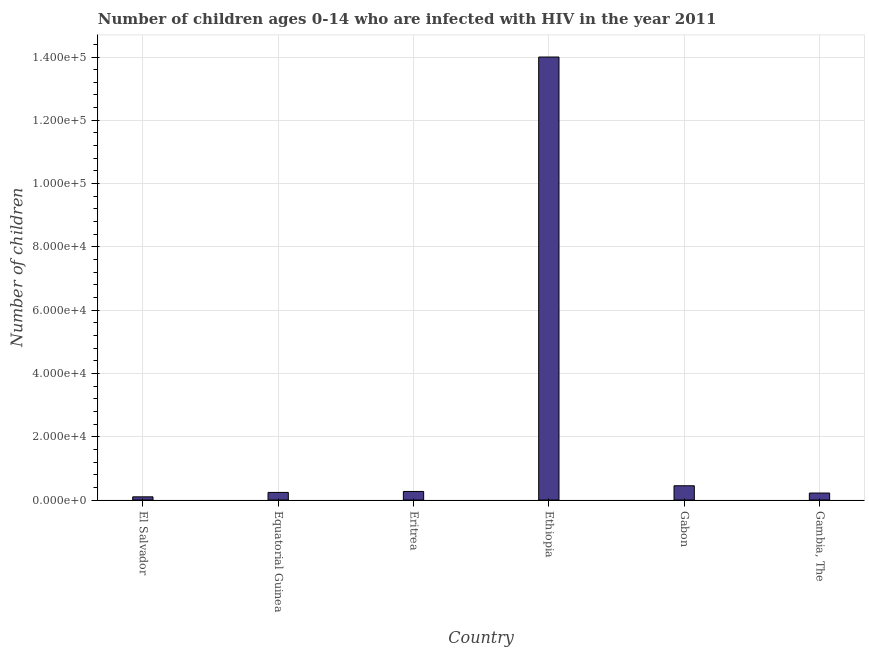Does the graph contain any zero values?
Your answer should be very brief. No. What is the title of the graph?
Provide a short and direct response. Number of children ages 0-14 who are infected with HIV in the year 2011. What is the label or title of the Y-axis?
Make the answer very short. Number of children. What is the number of children living with hiv in Gambia, The?
Your response must be concise. 2200. Across all countries, what is the maximum number of children living with hiv?
Your answer should be very brief. 1.40e+05. In which country was the number of children living with hiv maximum?
Provide a short and direct response. Ethiopia. In which country was the number of children living with hiv minimum?
Your answer should be compact. El Salvador. What is the sum of the number of children living with hiv?
Provide a succinct answer. 1.53e+05. What is the difference between the number of children living with hiv in El Salvador and Eritrea?
Your response must be concise. -1700. What is the average number of children living with hiv per country?
Provide a succinct answer. 2.55e+04. What is the median number of children living with hiv?
Make the answer very short. 2550. In how many countries, is the number of children living with hiv greater than 16000 ?
Offer a very short reply. 1. What is the ratio of the number of children living with hiv in Ethiopia to that in Gabon?
Provide a succinct answer. 31.11. Is the difference between the number of children living with hiv in Equatorial Guinea and Gambia, The greater than the difference between any two countries?
Make the answer very short. No. What is the difference between the highest and the second highest number of children living with hiv?
Make the answer very short. 1.36e+05. What is the difference between the highest and the lowest number of children living with hiv?
Your answer should be very brief. 1.39e+05. How many bars are there?
Ensure brevity in your answer.  6. How many countries are there in the graph?
Your response must be concise. 6. What is the difference between two consecutive major ticks on the Y-axis?
Your answer should be very brief. 2.00e+04. What is the Number of children in Equatorial Guinea?
Your response must be concise. 2400. What is the Number of children in Eritrea?
Your answer should be very brief. 2700. What is the Number of children of Ethiopia?
Your response must be concise. 1.40e+05. What is the Number of children in Gabon?
Keep it short and to the point. 4500. What is the Number of children of Gambia, The?
Offer a terse response. 2200. What is the difference between the Number of children in El Salvador and Equatorial Guinea?
Your answer should be compact. -1400. What is the difference between the Number of children in El Salvador and Eritrea?
Ensure brevity in your answer.  -1700. What is the difference between the Number of children in El Salvador and Ethiopia?
Ensure brevity in your answer.  -1.39e+05. What is the difference between the Number of children in El Salvador and Gabon?
Your answer should be compact. -3500. What is the difference between the Number of children in El Salvador and Gambia, The?
Your response must be concise. -1200. What is the difference between the Number of children in Equatorial Guinea and Eritrea?
Keep it short and to the point. -300. What is the difference between the Number of children in Equatorial Guinea and Ethiopia?
Your answer should be compact. -1.38e+05. What is the difference between the Number of children in Equatorial Guinea and Gabon?
Provide a succinct answer. -2100. What is the difference between the Number of children in Eritrea and Ethiopia?
Provide a succinct answer. -1.37e+05. What is the difference between the Number of children in Eritrea and Gabon?
Provide a short and direct response. -1800. What is the difference between the Number of children in Ethiopia and Gabon?
Keep it short and to the point. 1.36e+05. What is the difference between the Number of children in Ethiopia and Gambia, The?
Give a very brief answer. 1.38e+05. What is the difference between the Number of children in Gabon and Gambia, The?
Provide a short and direct response. 2300. What is the ratio of the Number of children in El Salvador to that in Equatorial Guinea?
Make the answer very short. 0.42. What is the ratio of the Number of children in El Salvador to that in Eritrea?
Offer a terse response. 0.37. What is the ratio of the Number of children in El Salvador to that in Ethiopia?
Offer a terse response. 0.01. What is the ratio of the Number of children in El Salvador to that in Gabon?
Offer a terse response. 0.22. What is the ratio of the Number of children in El Salvador to that in Gambia, The?
Your response must be concise. 0.46. What is the ratio of the Number of children in Equatorial Guinea to that in Eritrea?
Give a very brief answer. 0.89. What is the ratio of the Number of children in Equatorial Guinea to that in Ethiopia?
Provide a short and direct response. 0.02. What is the ratio of the Number of children in Equatorial Guinea to that in Gabon?
Make the answer very short. 0.53. What is the ratio of the Number of children in Equatorial Guinea to that in Gambia, The?
Ensure brevity in your answer.  1.09. What is the ratio of the Number of children in Eritrea to that in Ethiopia?
Give a very brief answer. 0.02. What is the ratio of the Number of children in Eritrea to that in Gabon?
Your answer should be very brief. 0.6. What is the ratio of the Number of children in Eritrea to that in Gambia, The?
Your response must be concise. 1.23. What is the ratio of the Number of children in Ethiopia to that in Gabon?
Keep it short and to the point. 31.11. What is the ratio of the Number of children in Ethiopia to that in Gambia, The?
Make the answer very short. 63.64. What is the ratio of the Number of children in Gabon to that in Gambia, The?
Offer a terse response. 2.04. 